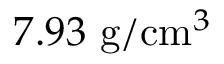Convert formula to latex. <formula><loc_0><loc_0><loc_500><loc_500>7 . 9 3 g / c m ^ { 3 }</formula> 